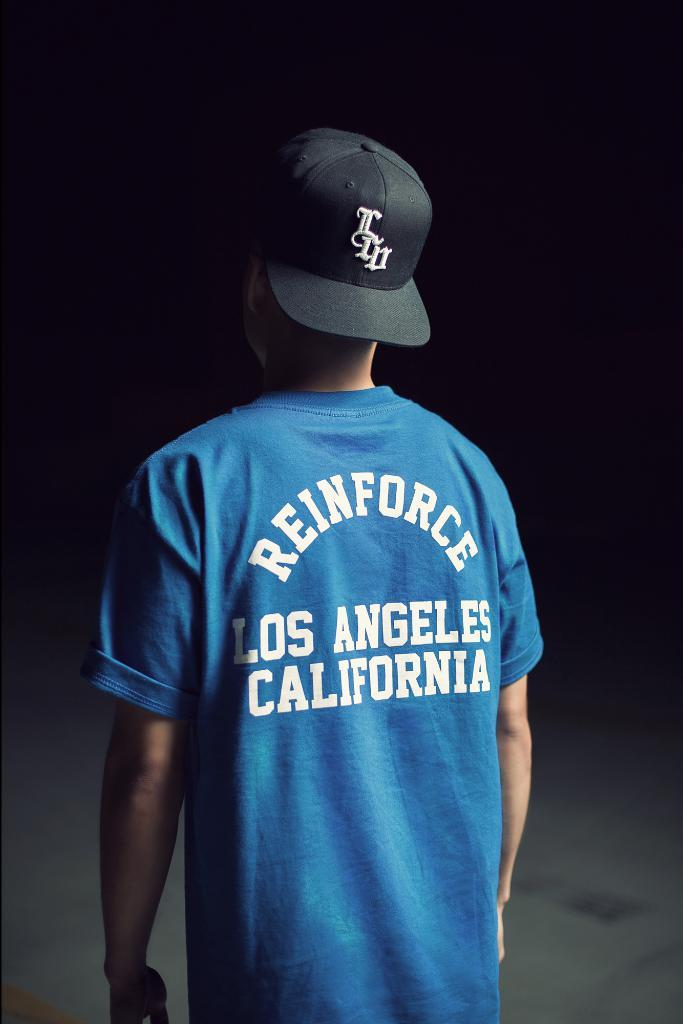<image>
Present a compact description of the photo's key features. The blue shirt is referring to a state in the US. 